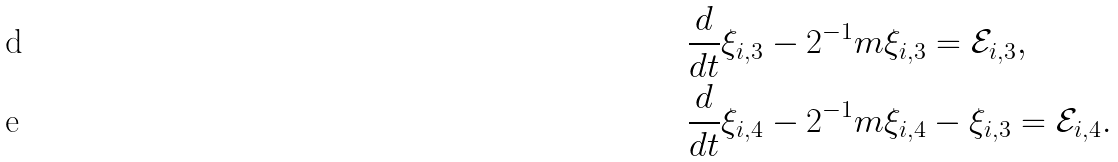<formula> <loc_0><loc_0><loc_500><loc_500>& \frac { d } { d t } \xi _ { i , 3 } - 2 ^ { - 1 } m \xi _ { i , 3 } = \mathcal { E } _ { i , 3 } , \\ & \frac { d } { d t } \xi _ { i , 4 } - 2 ^ { - 1 } m \xi _ { i , 4 } - \xi _ { i , 3 } = \mathcal { E } _ { i , 4 } .</formula> 